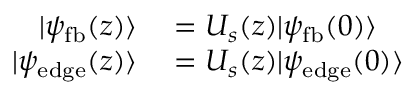<formula> <loc_0><loc_0><loc_500><loc_500>\begin{array} { r l } { | \psi _ { f b } ( z ) \rangle } & = U _ { s } ( z ) | \psi _ { f b } ( 0 ) \rangle } \\ { | \psi _ { e d g e } ( z ) \rangle } & = U _ { s } ( z ) | \psi _ { e d g e } ( 0 ) \rangle } \end{array}</formula> 